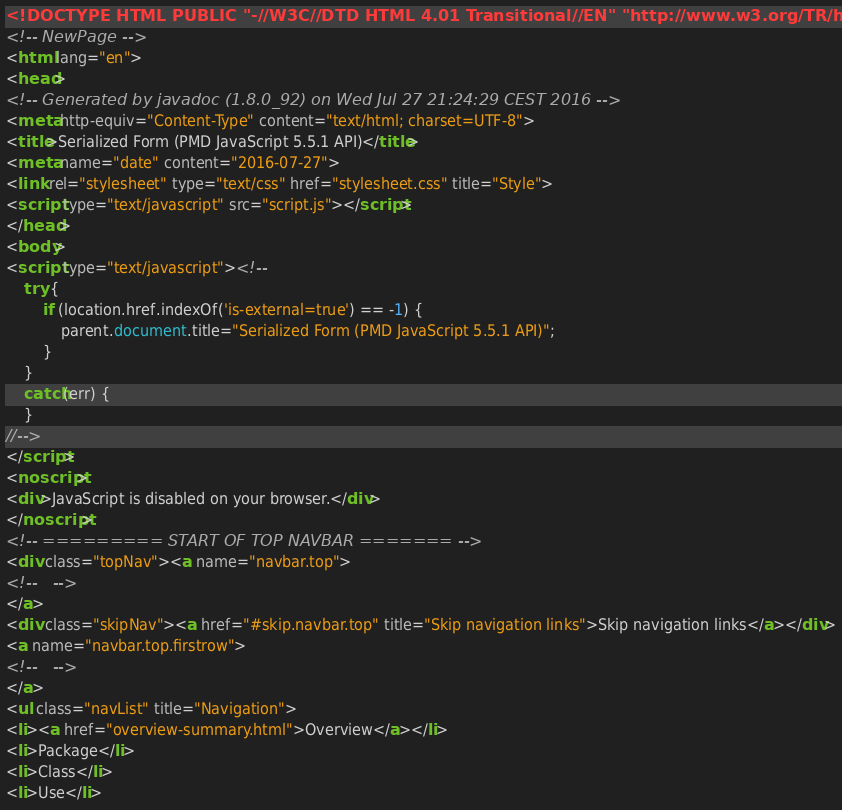Convert code to text. <code><loc_0><loc_0><loc_500><loc_500><_HTML_><!DOCTYPE HTML PUBLIC "-//W3C//DTD HTML 4.01 Transitional//EN" "http://www.w3.org/TR/html4/loose.dtd">
<!-- NewPage -->
<html lang="en">
<head>
<!-- Generated by javadoc (1.8.0_92) on Wed Jul 27 21:24:29 CEST 2016 -->
<meta http-equiv="Content-Type" content="text/html; charset=UTF-8">
<title>Serialized Form (PMD JavaScript 5.5.1 API)</title>
<meta name="date" content="2016-07-27">
<link rel="stylesheet" type="text/css" href="stylesheet.css" title="Style">
<script type="text/javascript" src="script.js"></script>
</head>
<body>
<script type="text/javascript"><!--
    try {
        if (location.href.indexOf('is-external=true') == -1) {
            parent.document.title="Serialized Form (PMD JavaScript 5.5.1 API)";
        }
    }
    catch(err) {
    }
//-->
</script>
<noscript>
<div>JavaScript is disabled on your browser.</div>
</noscript>
<!-- ========= START OF TOP NAVBAR ======= -->
<div class="topNav"><a name="navbar.top">
<!--   -->
</a>
<div class="skipNav"><a href="#skip.navbar.top" title="Skip navigation links">Skip navigation links</a></div>
<a name="navbar.top.firstrow">
<!--   -->
</a>
<ul class="navList" title="Navigation">
<li><a href="overview-summary.html">Overview</a></li>
<li>Package</li>
<li>Class</li>
<li>Use</li></code> 